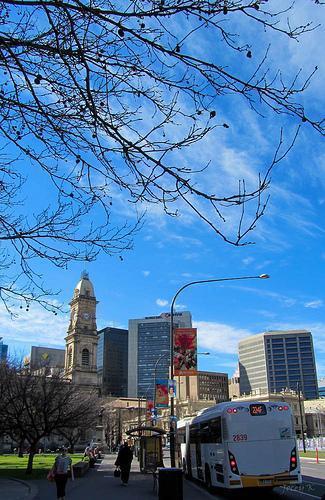How many light pole banners are visible?
Give a very brief answer. 3. How many busses are in the picture?
Give a very brief answer. 1. 